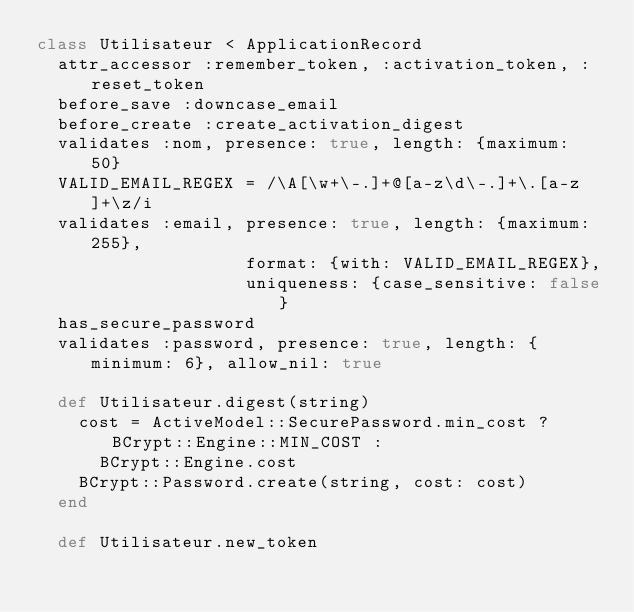Convert code to text. <code><loc_0><loc_0><loc_500><loc_500><_Ruby_>class Utilisateur < ApplicationRecord
  attr_accessor :remember_token, :activation_token, :reset_token
  before_save :downcase_email
  before_create :create_activation_digest
  validates :nom, presence: true, length: {maximum: 50}
  VALID_EMAIL_REGEX = /\A[\w+\-.]+@[a-z\d\-.]+\.[a-z]+\z/i
  validates :email, presence: true, length: {maximum: 255},
                    format: {with: VALID_EMAIL_REGEX},
                    uniqueness: {case_sensitive: false}
  has_secure_password
  validates :password, presence: true, length: {minimum: 6}, allow_nil: true

  def Utilisateur.digest(string)
    cost = ActiveModel::SecurePassword.min_cost ? BCrypt::Engine::MIN_COST :
      BCrypt::Engine.cost
    BCrypt::Password.create(string, cost: cost)
  end

  def Utilisateur.new_token</code> 